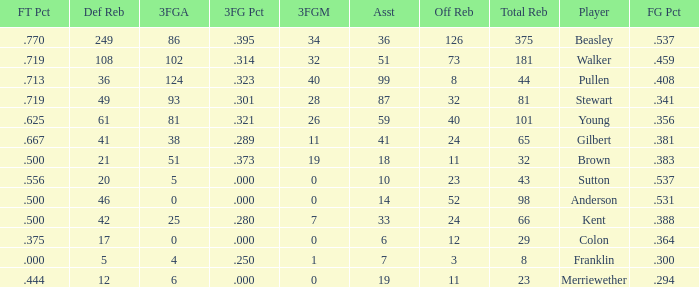What is the total number of offensive rebounds for players with more than 124 3-point attempts? 0.0. 